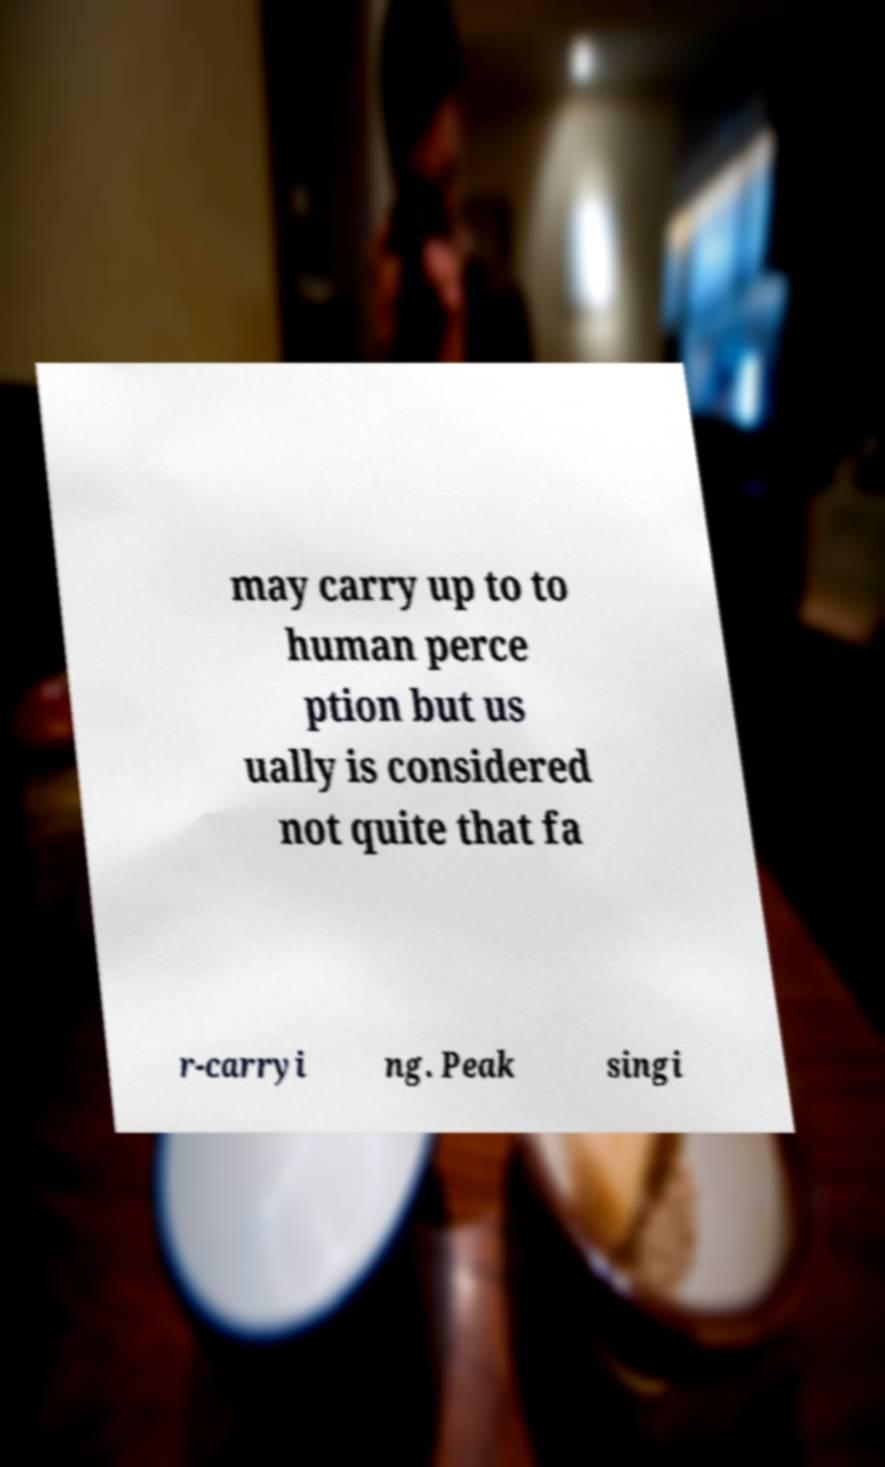Can you read and provide the text displayed in the image?This photo seems to have some interesting text. Can you extract and type it out for me? may carry up to to human perce ption but us ually is considered not quite that fa r-carryi ng. Peak singi 